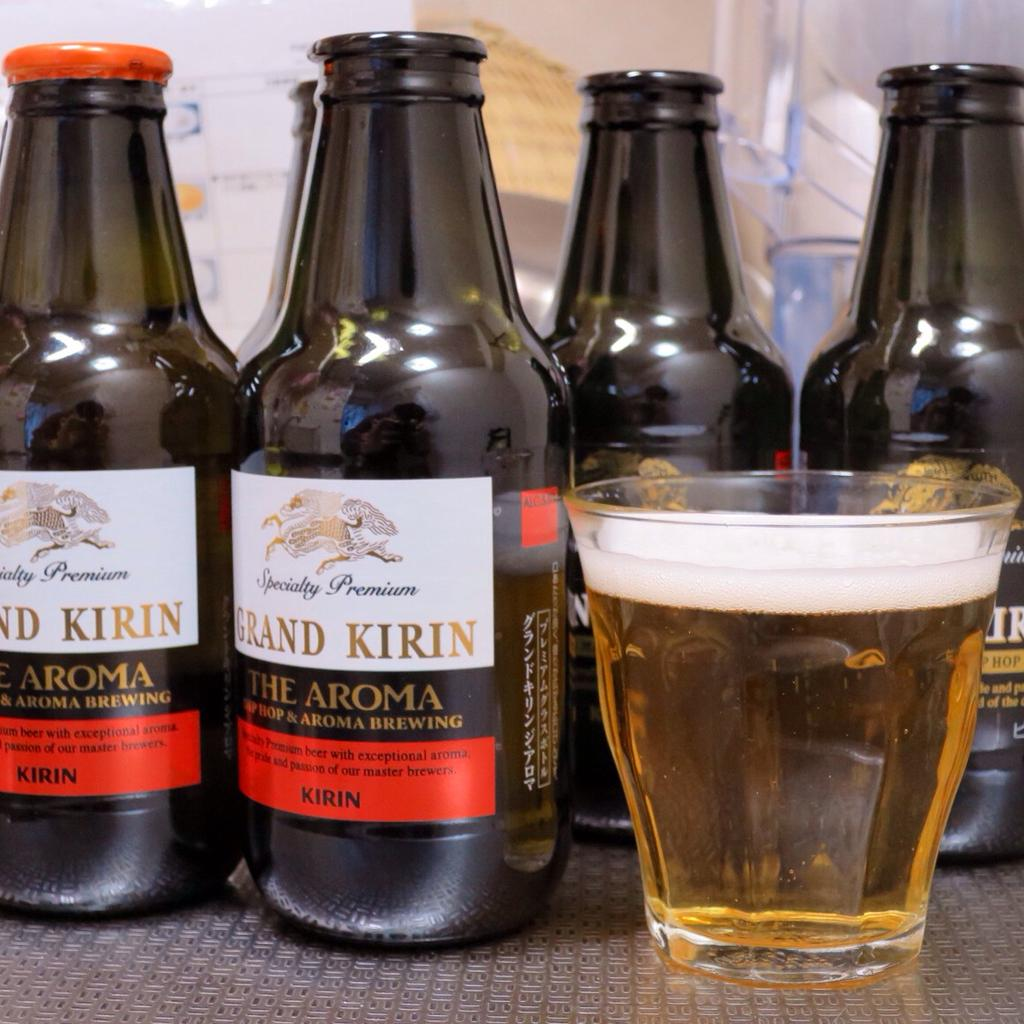<image>
Create a compact narrative representing the image presented. small beer bottles that say grand kirin the aroma on them 